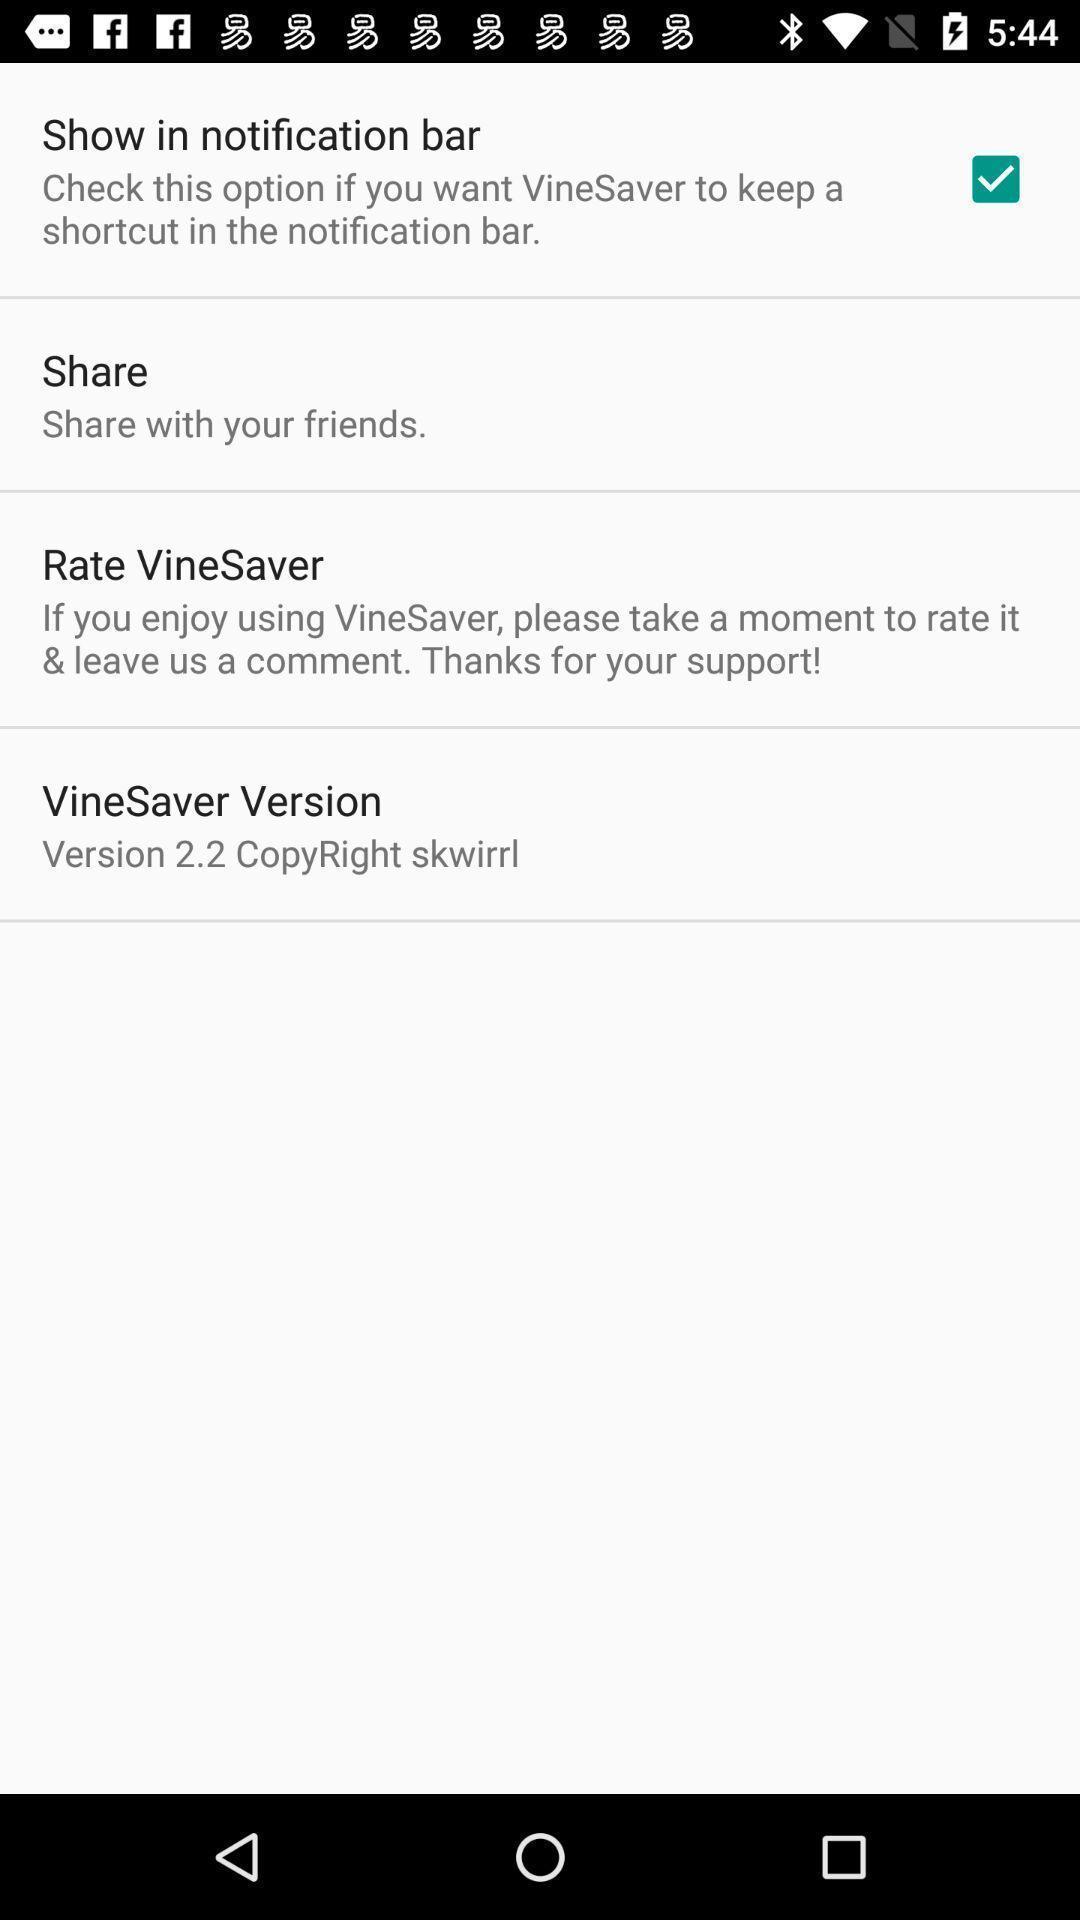Give me a summary of this screen capture. Setting page for notifications. 